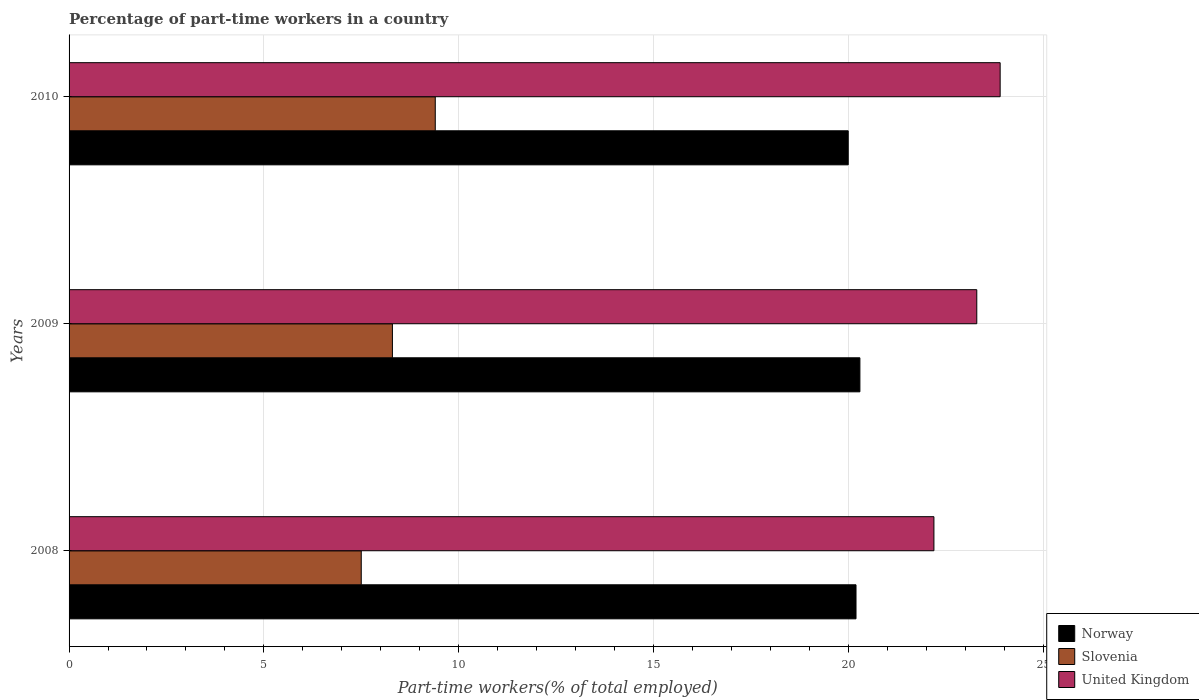How many different coloured bars are there?
Provide a succinct answer. 3. Are the number of bars per tick equal to the number of legend labels?
Offer a very short reply. Yes. Are the number of bars on each tick of the Y-axis equal?
Provide a succinct answer. Yes. How many bars are there on the 2nd tick from the bottom?
Your answer should be very brief. 3. In how many cases, is the number of bars for a given year not equal to the number of legend labels?
Offer a terse response. 0. What is the percentage of part-time workers in Norway in 2008?
Your answer should be very brief. 20.2. Across all years, what is the maximum percentage of part-time workers in Slovenia?
Provide a succinct answer. 9.4. Across all years, what is the minimum percentage of part-time workers in United Kingdom?
Your response must be concise. 22.2. In which year was the percentage of part-time workers in Norway minimum?
Ensure brevity in your answer.  2010. What is the total percentage of part-time workers in Slovenia in the graph?
Ensure brevity in your answer.  25.2. What is the difference between the percentage of part-time workers in Norway in 2008 and that in 2009?
Keep it short and to the point. -0.1. What is the difference between the percentage of part-time workers in United Kingdom in 2010 and the percentage of part-time workers in Norway in 2008?
Ensure brevity in your answer.  3.7. What is the average percentage of part-time workers in Norway per year?
Provide a short and direct response. 20.17. In the year 2008, what is the difference between the percentage of part-time workers in Slovenia and percentage of part-time workers in United Kingdom?
Your response must be concise. -14.7. In how many years, is the percentage of part-time workers in Slovenia greater than 4 %?
Make the answer very short. 3. What is the ratio of the percentage of part-time workers in Norway in 2008 to that in 2009?
Offer a terse response. 1. Is the percentage of part-time workers in United Kingdom in 2009 less than that in 2010?
Make the answer very short. Yes. What is the difference between the highest and the second highest percentage of part-time workers in Slovenia?
Provide a succinct answer. 1.1. What is the difference between the highest and the lowest percentage of part-time workers in Norway?
Provide a succinct answer. 0.3. In how many years, is the percentage of part-time workers in United Kingdom greater than the average percentage of part-time workers in United Kingdom taken over all years?
Make the answer very short. 2. Is the sum of the percentage of part-time workers in Norway in 2008 and 2010 greater than the maximum percentage of part-time workers in United Kingdom across all years?
Offer a terse response. Yes. How many bars are there?
Your answer should be compact. 9. How are the legend labels stacked?
Offer a very short reply. Vertical. What is the title of the graph?
Your answer should be very brief. Percentage of part-time workers in a country. Does "Middle East & North Africa (all income levels)" appear as one of the legend labels in the graph?
Keep it short and to the point. No. What is the label or title of the X-axis?
Keep it short and to the point. Part-time workers(% of total employed). What is the label or title of the Y-axis?
Provide a succinct answer. Years. What is the Part-time workers(% of total employed) in Norway in 2008?
Your response must be concise. 20.2. What is the Part-time workers(% of total employed) of Slovenia in 2008?
Your response must be concise. 7.5. What is the Part-time workers(% of total employed) in United Kingdom in 2008?
Offer a very short reply. 22.2. What is the Part-time workers(% of total employed) of Norway in 2009?
Offer a terse response. 20.3. What is the Part-time workers(% of total employed) of Slovenia in 2009?
Offer a terse response. 8.3. What is the Part-time workers(% of total employed) of United Kingdom in 2009?
Provide a succinct answer. 23.3. What is the Part-time workers(% of total employed) of Norway in 2010?
Offer a very short reply. 20. What is the Part-time workers(% of total employed) of Slovenia in 2010?
Make the answer very short. 9.4. What is the Part-time workers(% of total employed) in United Kingdom in 2010?
Offer a very short reply. 23.9. Across all years, what is the maximum Part-time workers(% of total employed) in Norway?
Provide a succinct answer. 20.3. Across all years, what is the maximum Part-time workers(% of total employed) of Slovenia?
Your answer should be very brief. 9.4. Across all years, what is the maximum Part-time workers(% of total employed) of United Kingdom?
Provide a succinct answer. 23.9. Across all years, what is the minimum Part-time workers(% of total employed) of United Kingdom?
Provide a short and direct response. 22.2. What is the total Part-time workers(% of total employed) in Norway in the graph?
Offer a very short reply. 60.5. What is the total Part-time workers(% of total employed) in Slovenia in the graph?
Provide a short and direct response. 25.2. What is the total Part-time workers(% of total employed) in United Kingdom in the graph?
Your answer should be very brief. 69.4. What is the difference between the Part-time workers(% of total employed) of Norway in 2008 and that in 2009?
Your answer should be very brief. -0.1. What is the difference between the Part-time workers(% of total employed) in Slovenia in 2008 and that in 2009?
Keep it short and to the point. -0.8. What is the difference between the Part-time workers(% of total employed) in Norway in 2008 and that in 2010?
Ensure brevity in your answer.  0.2. What is the difference between the Part-time workers(% of total employed) of Slovenia in 2008 and that in 2010?
Your answer should be very brief. -1.9. What is the difference between the Part-time workers(% of total employed) of United Kingdom in 2009 and that in 2010?
Offer a terse response. -0.6. What is the difference between the Part-time workers(% of total employed) of Norway in 2008 and the Part-time workers(% of total employed) of United Kingdom in 2009?
Offer a terse response. -3.1. What is the difference between the Part-time workers(% of total employed) in Slovenia in 2008 and the Part-time workers(% of total employed) in United Kingdom in 2009?
Offer a terse response. -15.8. What is the difference between the Part-time workers(% of total employed) in Norway in 2008 and the Part-time workers(% of total employed) in United Kingdom in 2010?
Your answer should be very brief. -3.7. What is the difference between the Part-time workers(% of total employed) of Slovenia in 2008 and the Part-time workers(% of total employed) of United Kingdom in 2010?
Provide a succinct answer. -16.4. What is the difference between the Part-time workers(% of total employed) in Norway in 2009 and the Part-time workers(% of total employed) in United Kingdom in 2010?
Offer a very short reply. -3.6. What is the difference between the Part-time workers(% of total employed) in Slovenia in 2009 and the Part-time workers(% of total employed) in United Kingdom in 2010?
Provide a succinct answer. -15.6. What is the average Part-time workers(% of total employed) of Norway per year?
Your response must be concise. 20.17. What is the average Part-time workers(% of total employed) in Slovenia per year?
Provide a succinct answer. 8.4. What is the average Part-time workers(% of total employed) in United Kingdom per year?
Keep it short and to the point. 23.13. In the year 2008, what is the difference between the Part-time workers(% of total employed) in Slovenia and Part-time workers(% of total employed) in United Kingdom?
Offer a terse response. -14.7. In the year 2009, what is the difference between the Part-time workers(% of total employed) in Norway and Part-time workers(% of total employed) in Slovenia?
Ensure brevity in your answer.  12. In the year 2009, what is the difference between the Part-time workers(% of total employed) in Slovenia and Part-time workers(% of total employed) in United Kingdom?
Keep it short and to the point. -15. In the year 2010, what is the difference between the Part-time workers(% of total employed) in Norway and Part-time workers(% of total employed) in Slovenia?
Give a very brief answer. 10.6. In the year 2010, what is the difference between the Part-time workers(% of total employed) of Slovenia and Part-time workers(% of total employed) of United Kingdom?
Ensure brevity in your answer.  -14.5. What is the ratio of the Part-time workers(% of total employed) of Norway in 2008 to that in 2009?
Offer a terse response. 1. What is the ratio of the Part-time workers(% of total employed) in Slovenia in 2008 to that in 2009?
Give a very brief answer. 0.9. What is the ratio of the Part-time workers(% of total employed) of United Kingdom in 2008 to that in 2009?
Ensure brevity in your answer.  0.95. What is the ratio of the Part-time workers(% of total employed) in Slovenia in 2008 to that in 2010?
Offer a terse response. 0.8. What is the ratio of the Part-time workers(% of total employed) in United Kingdom in 2008 to that in 2010?
Provide a short and direct response. 0.93. What is the ratio of the Part-time workers(% of total employed) of Slovenia in 2009 to that in 2010?
Provide a short and direct response. 0.88. What is the ratio of the Part-time workers(% of total employed) in United Kingdom in 2009 to that in 2010?
Provide a short and direct response. 0.97. What is the difference between the highest and the second highest Part-time workers(% of total employed) of Norway?
Make the answer very short. 0.1. What is the difference between the highest and the second highest Part-time workers(% of total employed) in Slovenia?
Give a very brief answer. 1.1. What is the difference between the highest and the lowest Part-time workers(% of total employed) in Norway?
Your answer should be very brief. 0.3. What is the difference between the highest and the lowest Part-time workers(% of total employed) of United Kingdom?
Make the answer very short. 1.7. 